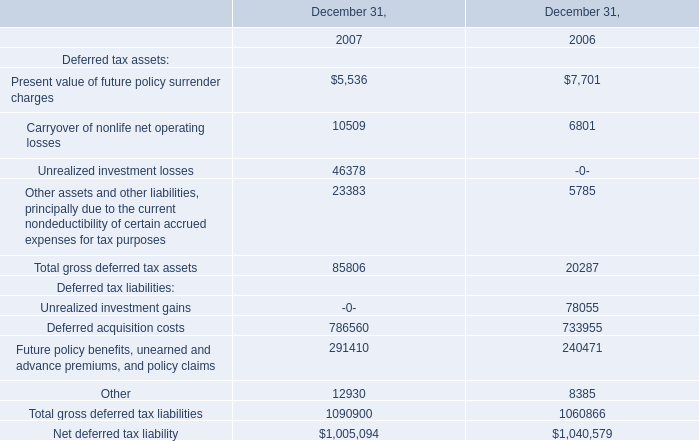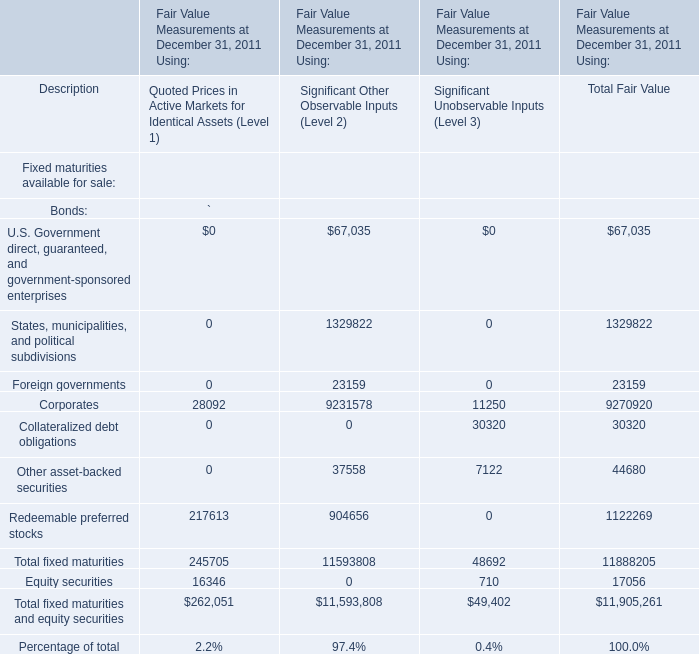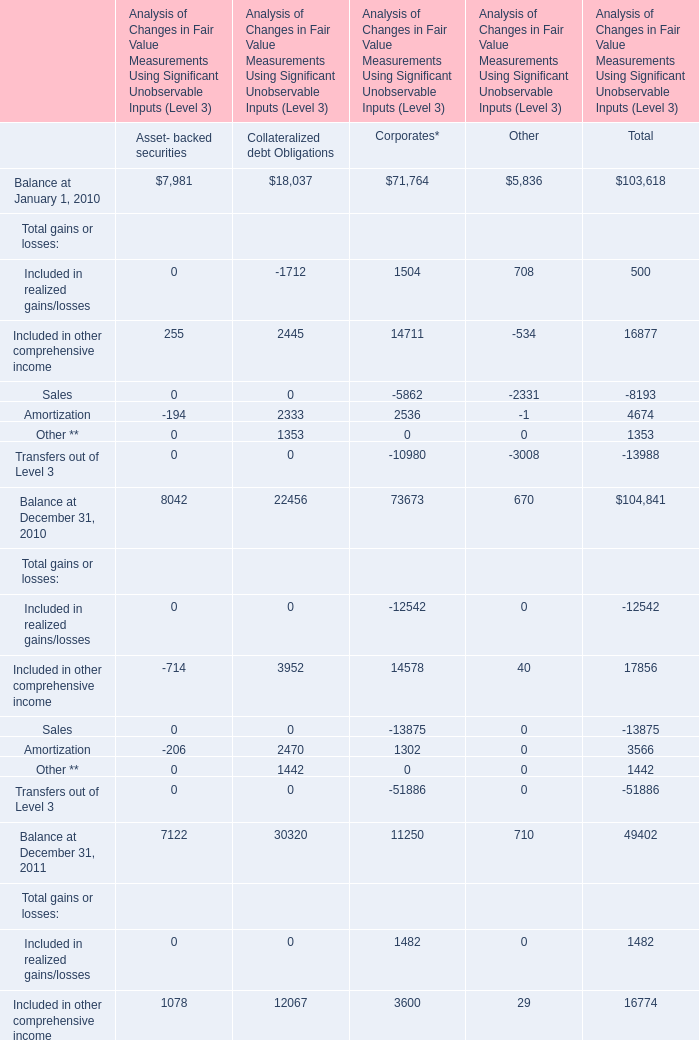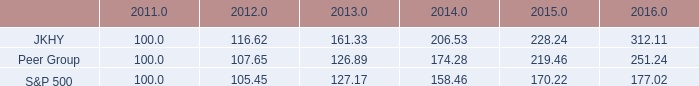what was the total amount of returns that jkhy , peer group and s&p 500 had made combined by june 30 , 2012? 
Computations: ((105.45 - 100) + ((116.62 - 100) + (107.65 - 100)))
Answer: 29.72. 